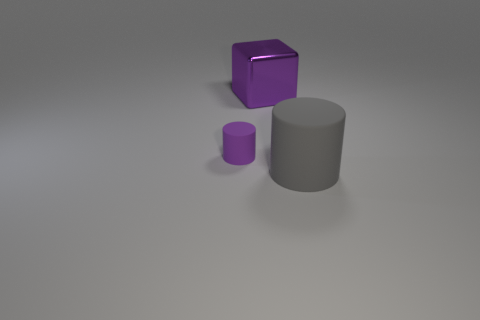Subtract all yellow cylinders. Subtract all brown balls. How many cylinders are left? 2 Add 2 brown metal balls. How many objects exist? 5 Subtract all blocks. How many objects are left? 2 Subtract 0 blue cylinders. How many objects are left? 3 Subtract all purple blocks. Subtract all small purple matte objects. How many objects are left? 1 Add 3 small matte things. How many small matte things are left? 4 Add 3 rubber objects. How many rubber objects exist? 5 